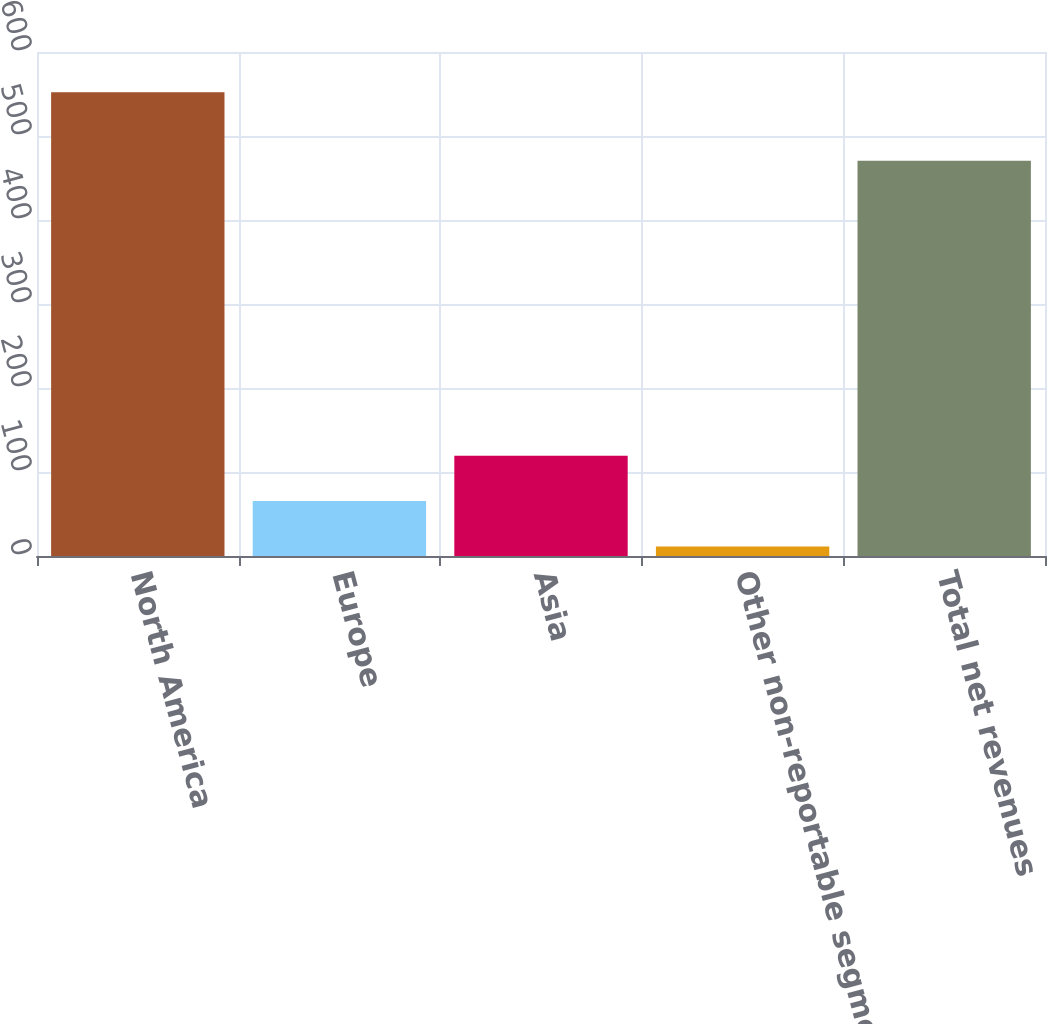<chart> <loc_0><loc_0><loc_500><loc_500><bar_chart><fcel>North America<fcel>Europe<fcel>Asia<fcel>Other non-reportable segments<fcel>Total net revenues<nl><fcel>552<fcel>65.37<fcel>119.44<fcel>11.3<fcel>470.5<nl></chart> 